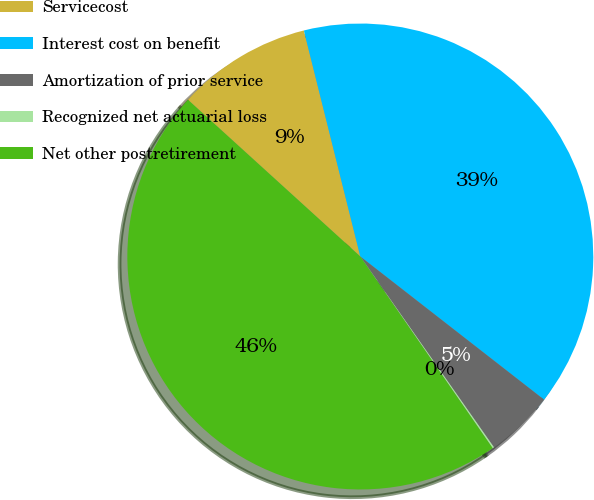Convert chart. <chart><loc_0><loc_0><loc_500><loc_500><pie_chart><fcel>Servicecost<fcel>Interest cost on benefit<fcel>Amortization of prior service<fcel>Recognized net actuarial loss<fcel>Net other postretirement<nl><fcel>9.36%<fcel>39.43%<fcel>4.74%<fcel>0.11%<fcel>46.36%<nl></chart> 